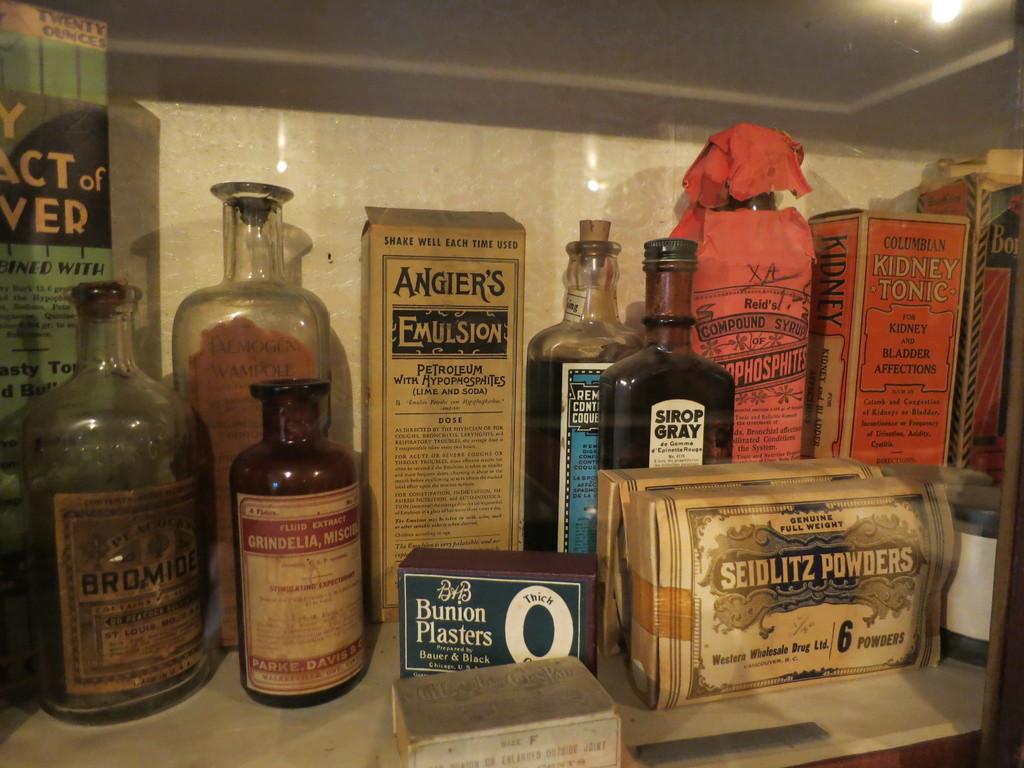Where is the box of powder located?
Ensure brevity in your answer.  Bottom right. 